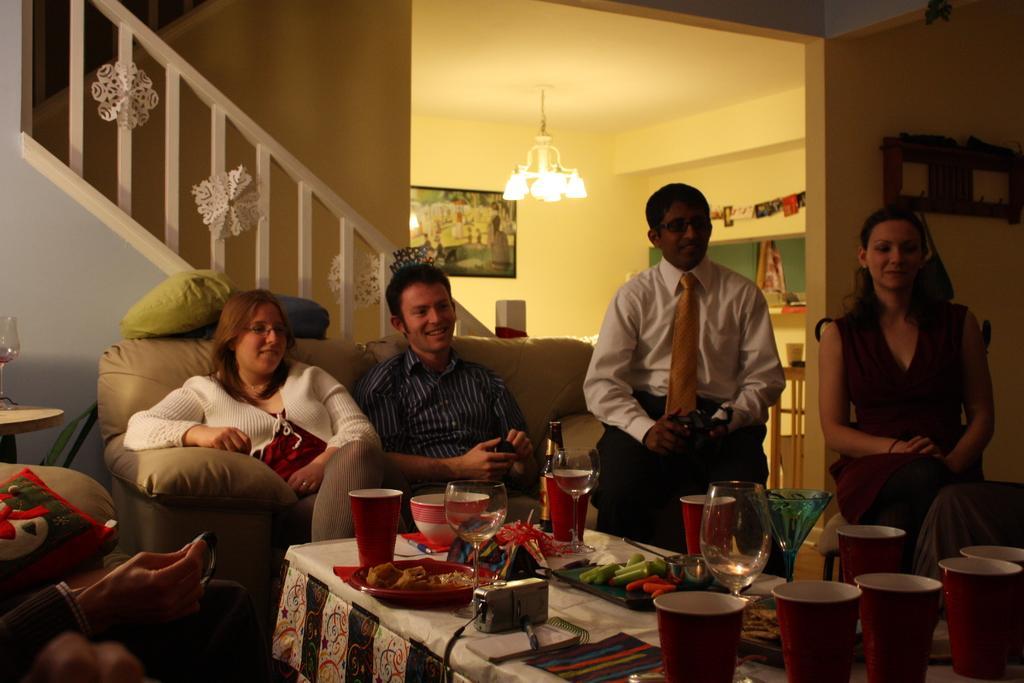Describe this image in one or two sentences. In the middle of an image there is a table,there are glasses,plates,food on this table a woman and a man are sitting on the sofa and he is smiling. Right side of an image there is a woman who is smiling behind her there is a wall and light and in the left side of an image there is a staircase. 